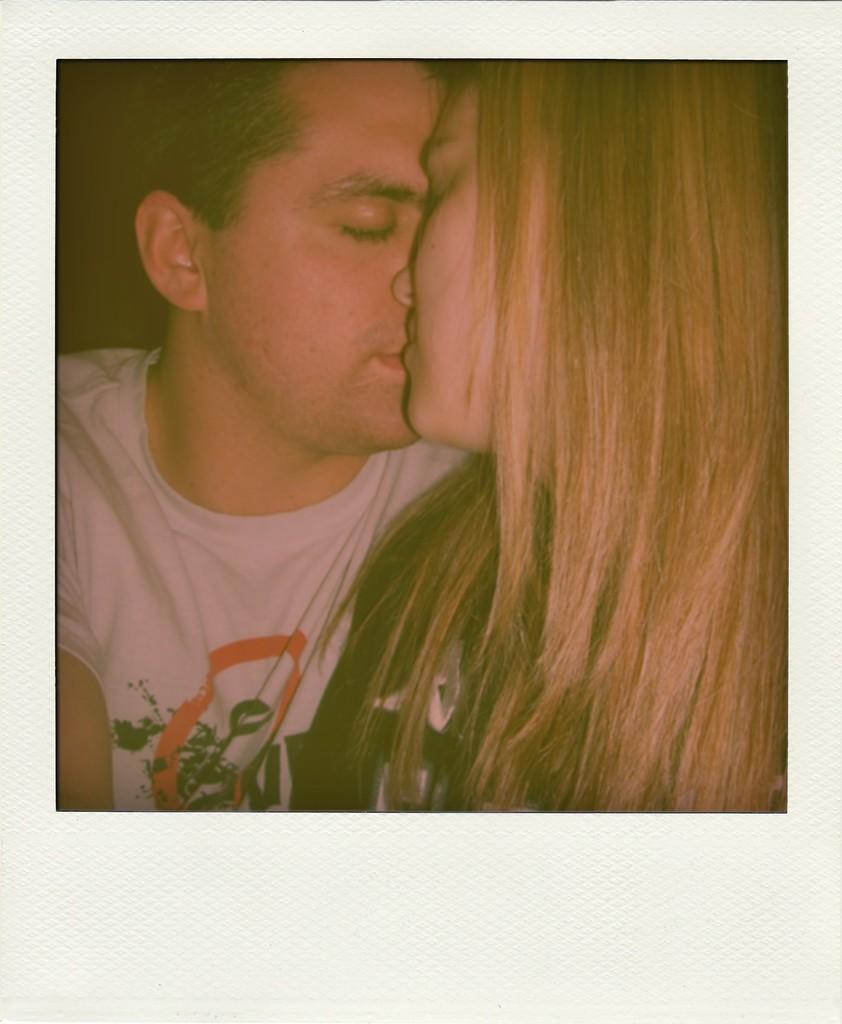Could you give a brief overview of what you see in this image? In this image we can see a man and a woman kissing each other. 